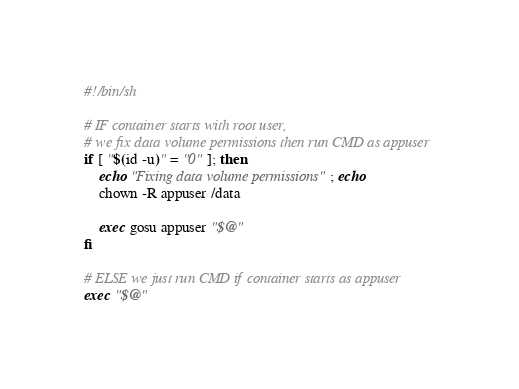<code> <loc_0><loc_0><loc_500><loc_500><_Bash_>#!/bin/sh

# IF container starts with root user,
# we fix data volume permissions then run CMD as appuser
if [ "$(id -u)" = "0" ]; then
    echo "Fixing data volume permissions"; echo
    chown -R appuser /data

    exec gosu appuser "$@"
fi

# ELSE we just run CMD if container starts as appuser
exec "$@"
</code> 